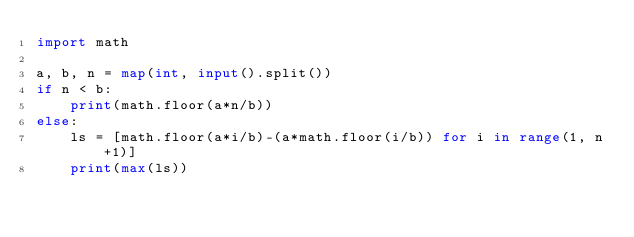Convert code to text. <code><loc_0><loc_0><loc_500><loc_500><_Python_>import math 

a, b, n = map(int, input().split())
if n < b:
    print(math.floor(a*n/b))
else:
    ls = [math.floor(a*i/b)-(a*math.floor(i/b)) for i in range(1, n+1)]
    print(max(ls))</code> 